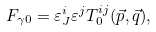Convert formula to latex. <formula><loc_0><loc_0><loc_500><loc_500>F _ { \gamma 0 } = \varepsilon _ { J } ^ { i } \varepsilon ^ { j } T _ { 0 } ^ { i j } ( \vec { p } , \vec { q } ) ,</formula> 